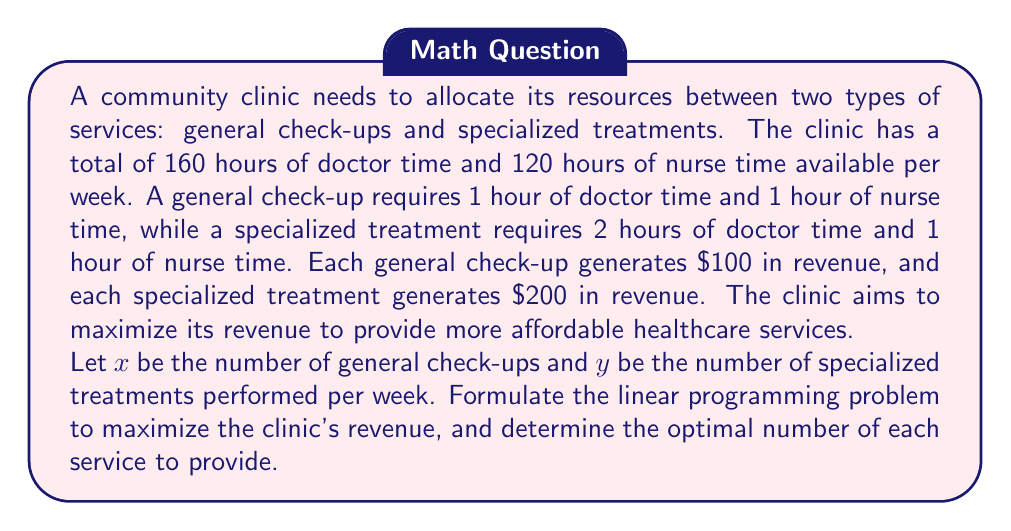Give your solution to this math problem. To solve this problem, we'll follow these steps:

1. Define the objective function
2. Identify the constraints
3. Set up the linear programming problem
4. Solve the problem using the graphical method

Step 1: Define the objective function

The objective is to maximize revenue. Let R be the total revenue.
$$R = 100x + 200y$$

Step 2: Identify the constraints

Doctor time constraint: $x + 2y \leq 160$
Nurse time constraint: $x + y \leq 120$
Non-negativity constraints: $x \geq 0, y \geq 0$

Step 3: Set up the linear programming problem

Maximize: $R = 100x + 200y$
Subject to:
$$x + 2y \leq 160$$
$$x + y \leq 120$$
$$x \geq 0, y \geq 0$$

Step 4: Solve the problem using the graphical method

a) Plot the constraints:
   - $x + 2y = 160$ intersects at (160, 0) and (0, 80)
   - $x + y = 120$ intersects at (120, 0) and (0, 120)

b) Identify the feasible region:
   The feasible region is the area bounded by these lines and the positive x and y axes.

c) Find the corner points of the feasible region:
   - (0, 0)
   - (120, 0)
   - (80, 40)
   - (0, 80)

d) Evaluate the objective function at each corner point:
   - (0, 0): R = 0
   - (120, 0): R = 12,000
   - (80, 40): R = 16,000
   - (0, 80): R = 16,000

The maximum revenue occurs at the point (80, 40).
Answer: The optimal solution is to provide 80 general check-ups and 40 specialized treatments per week, which will generate a maximum revenue of $16,000. 